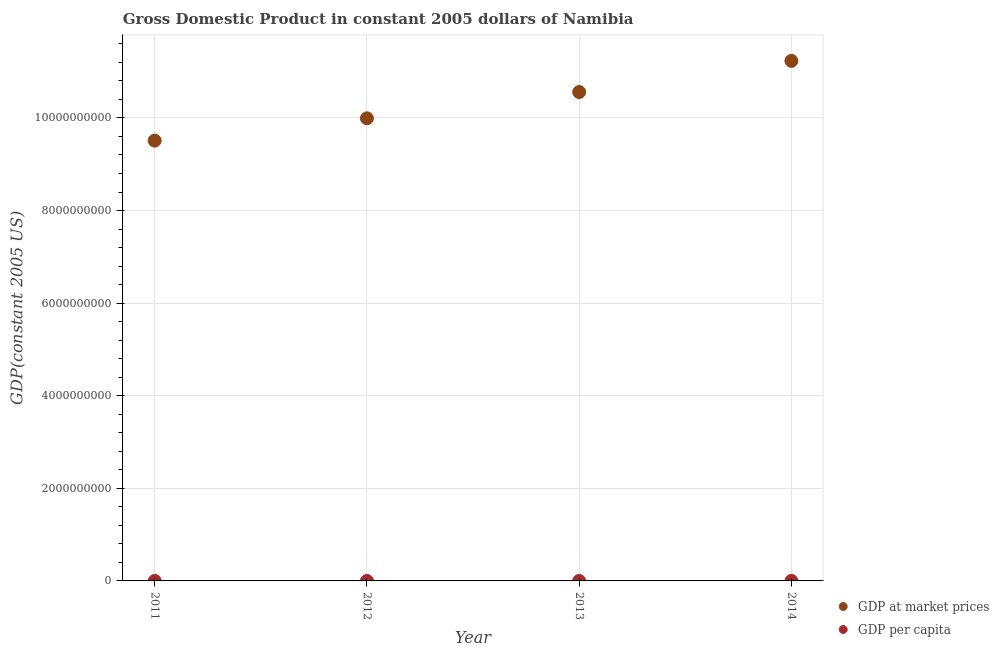What is the gdp per capita in 2014?
Offer a very short reply. 4674.63. Across all years, what is the maximum gdp at market prices?
Your response must be concise. 1.12e+1. Across all years, what is the minimum gdp at market prices?
Provide a short and direct response. 9.51e+09. In which year was the gdp per capita maximum?
Provide a succinct answer. 2014. In which year was the gdp per capita minimum?
Offer a terse response. 2011. What is the total gdp per capita in the graph?
Offer a terse response. 1.78e+04. What is the difference between the gdp at market prices in 2011 and that in 2012?
Keep it short and to the point. -4.82e+08. What is the difference between the gdp at market prices in 2011 and the gdp per capita in 2014?
Provide a short and direct response. 9.51e+09. What is the average gdp per capita per year?
Your answer should be very brief. 4445.05. In the year 2013, what is the difference between the gdp at market prices and gdp per capita?
Ensure brevity in your answer.  1.06e+1. What is the ratio of the gdp per capita in 2012 to that in 2013?
Your response must be concise. 0.97. Is the gdp at market prices in 2011 less than that in 2014?
Make the answer very short. Yes. Is the difference between the gdp at market prices in 2011 and 2013 greater than the difference between the gdp per capita in 2011 and 2013?
Your answer should be very brief. No. What is the difference between the highest and the second highest gdp at market prices?
Your answer should be very brief. 6.73e+08. What is the difference between the highest and the lowest gdp per capita?
Your answer should be very brief. 429.22. Does the gdp at market prices monotonically increase over the years?
Keep it short and to the point. Yes. How many dotlines are there?
Your answer should be very brief. 2. Are the values on the major ticks of Y-axis written in scientific E-notation?
Your answer should be compact. No. Does the graph contain grids?
Give a very brief answer. Yes. How many legend labels are there?
Ensure brevity in your answer.  2. What is the title of the graph?
Your answer should be compact. Gross Domestic Product in constant 2005 dollars of Namibia. Does "Current US$" appear as one of the legend labels in the graph?
Your answer should be compact. No. What is the label or title of the Y-axis?
Make the answer very short. GDP(constant 2005 US). What is the GDP(constant 2005 US) in GDP at market prices in 2011?
Make the answer very short. 9.51e+09. What is the GDP(constant 2005 US) in GDP per capita in 2011?
Provide a succinct answer. 4245.41. What is the GDP(constant 2005 US) in GDP at market prices in 2012?
Your response must be concise. 9.99e+09. What is the GDP(constant 2005 US) of GDP per capita in 2012?
Ensure brevity in your answer.  4360.19. What is the GDP(constant 2005 US) of GDP at market prices in 2013?
Make the answer very short. 1.06e+1. What is the GDP(constant 2005 US) of GDP per capita in 2013?
Provide a succinct answer. 4499.97. What is the GDP(constant 2005 US) in GDP at market prices in 2014?
Offer a terse response. 1.12e+1. What is the GDP(constant 2005 US) of GDP per capita in 2014?
Make the answer very short. 4674.63. Across all years, what is the maximum GDP(constant 2005 US) of GDP at market prices?
Offer a terse response. 1.12e+1. Across all years, what is the maximum GDP(constant 2005 US) of GDP per capita?
Keep it short and to the point. 4674.63. Across all years, what is the minimum GDP(constant 2005 US) in GDP at market prices?
Provide a succinct answer. 9.51e+09. Across all years, what is the minimum GDP(constant 2005 US) in GDP per capita?
Provide a succinct answer. 4245.41. What is the total GDP(constant 2005 US) in GDP at market prices in the graph?
Ensure brevity in your answer.  4.13e+1. What is the total GDP(constant 2005 US) of GDP per capita in the graph?
Ensure brevity in your answer.  1.78e+04. What is the difference between the GDP(constant 2005 US) in GDP at market prices in 2011 and that in 2012?
Keep it short and to the point. -4.82e+08. What is the difference between the GDP(constant 2005 US) in GDP per capita in 2011 and that in 2012?
Offer a very short reply. -114.78. What is the difference between the GDP(constant 2005 US) of GDP at market prices in 2011 and that in 2013?
Offer a terse response. -1.05e+09. What is the difference between the GDP(constant 2005 US) of GDP per capita in 2011 and that in 2013?
Provide a short and direct response. -254.55. What is the difference between the GDP(constant 2005 US) of GDP at market prices in 2011 and that in 2014?
Keep it short and to the point. -1.72e+09. What is the difference between the GDP(constant 2005 US) of GDP per capita in 2011 and that in 2014?
Provide a succinct answer. -429.22. What is the difference between the GDP(constant 2005 US) of GDP at market prices in 2012 and that in 2013?
Keep it short and to the point. -5.68e+08. What is the difference between the GDP(constant 2005 US) in GDP per capita in 2012 and that in 2013?
Provide a succinct answer. -139.78. What is the difference between the GDP(constant 2005 US) of GDP at market prices in 2012 and that in 2014?
Ensure brevity in your answer.  -1.24e+09. What is the difference between the GDP(constant 2005 US) of GDP per capita in 2012 and that in 2014?
Make the answer very short. -314.44. What is the difference between the GDP(constant 2005 US) of GDP at market prices in 2013 and that in 2014?
Offer a very short reply. -6.73e+08. What is the difference between the GDP(constant 2005 US) of GDP per capita in 2013 and that in 2014?
Keep it short and to the point. -174.66. What is the difference between the GDP(constant 2005 US) in GDP at market prices in 2011 and the GDP(constant 2005 US) in GDP per capita in 2012?
Keep it short and to the point. 9.51e+09. What is the difference between the GDP(constant 2005 US) in GDP at market prices in 2011 and the GDP(constant 2005 US) in GDP per capita in 2013?
Keep it short and to the point. 9.51e+09. What is the difference between the GDP(constant 2005 US) of GDP at market prices in 2011 and the GDP(constant 2005 US) of GDP per capita in 2014?
Provide a short and direct response. 9.51e+09. What is the difference between the GDP(constant 2005 US) in GDP at market prices in 2012 and the GDP(constant 2005 US) in GDP per capita in 2013?
Give a very brief answer. 9.99e+09. What is the difference between the GDP(constant 2005 US) in GDP at market prices in 2012 and the GDP(constant 2005 US) in GDP per capita in 2014?
Your answer should be very brief. 9.99e+09. What is the difference between the GDP(constant 2005 US) of GDP at market prices in 2013 and the GDP(constant 2005 US) of GDP per capita in 2014?
Your answer should be very brief. 1.06e+1. What is the average GDP(constant 2005 US) in GDP at market prices per year?
Offer a very short reply. 1.03e+1. What is the average GDP(constant 2005 US) of GDP per capita per year?
Your answer should be very brief. 4445.05. In the year 2011, what is the difference between the GDP(constant 2005 US) of GDP at market prices and GDP(constant 2005 US) of GDP per capita?
Offer a terse response. 9.51e+09. In the year 2012, what is the difference between the GDP(constant 2005 US) of GDP at market prices and GDP(constant 2005 US) of GDP per capita?
Your answer should be compact. 9.99e+09. In the year 2013, what is the difference between the GDP(constant 2005 US) of GDP at market prices and GDP(constant 2005 US) of GDP per capita?
Make the answer very short. 1.06e+1. In the year 2014, what is the difference between the GDP(constant 2005 US) of GDP at market prices and GDP(constant 2005 US) of GDP per capita?
Give a very brief answer. 1.12e+1. What is the ratio of the GDP(constant 2005 US) of GDP at market prices in 2011 to that in 2012?
Offer a terse response. 0.95. What is the ratio of the GDP(constant 2005 US) in GDP per capita in 2011 to that in 2012?
Keep it short and to the point. 0.97. What is the ratio of the GDP(constant 2005 US) in GDP at market prices in 2011 to that in 2013?
Offer a very short reply. 0.9. What is the ratio of the GDP(constant 2005 US) of GDP per capita in 2011 to that in 2013?
Keep it short and to the point. 0.94. What is the ratio of the GDP(constant 2005 US) in GDP at market prices in 2011 to that in 2014?
Provide a succinct answer. 0.85. What is the ratio of the GDP(constant 2005 US) of GDP per capita in 2011 to that in 2014?
Offer a terse response. 0.91. What is the ratio of the GDP(constant 2005 US) in GDP at market prices in 2012 to that in 2013?
Your answer should be very brief. 0.95. What is the ratio of the GDP(constant 2005 US) of GDP per capita in 2012 to that in 2013?
Provide a succinct answer. 0.97. What is the ratio of the GDP(constant 2005 US) of GDP at market prices in 2012 to that in 2014?
Ensure brevity in your answer.  0.89. What is the ratio of the GDP(constant 2005 US) in GDP per capita in 2012 to that in 2014?
Give a very brief answer. 0.93. What is the ratio of the GDP(constant 2005 US) in GDP at market prices in 2013 to that in 2014?
Provide a succinct answer. 0.94. What is the ratio of the GDP(constant 2005 US) in GDP per capita in 2013 to that in 2014?
Your response must be concise. 0.96. What is the difference between the highest and the second highest GDP(constant 2005 US) of GDP at market prices?
Your response must be concise. 6.73e+08. What is the difference between the highest and the second highest GDP(constant 2005 US) in GDP per capita?
Your answer should be compact. 174.66. What is the difference between the highest and the lowest GDP(constant 2005 US) in GDP at market prices?
Make the answer very short. 1.72e+09. What is the difference between the highest and the lowest GDP(constant 2005 US) in GDP per capita?
Keep it short and to the point. 429.22. 